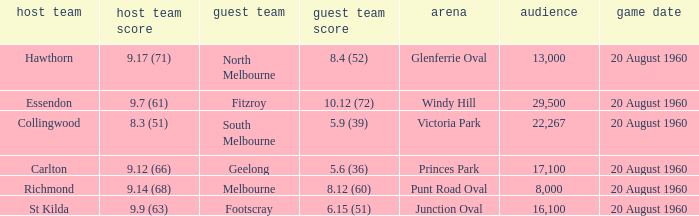What is the venue when Geelong is the away team? Princes Park. 